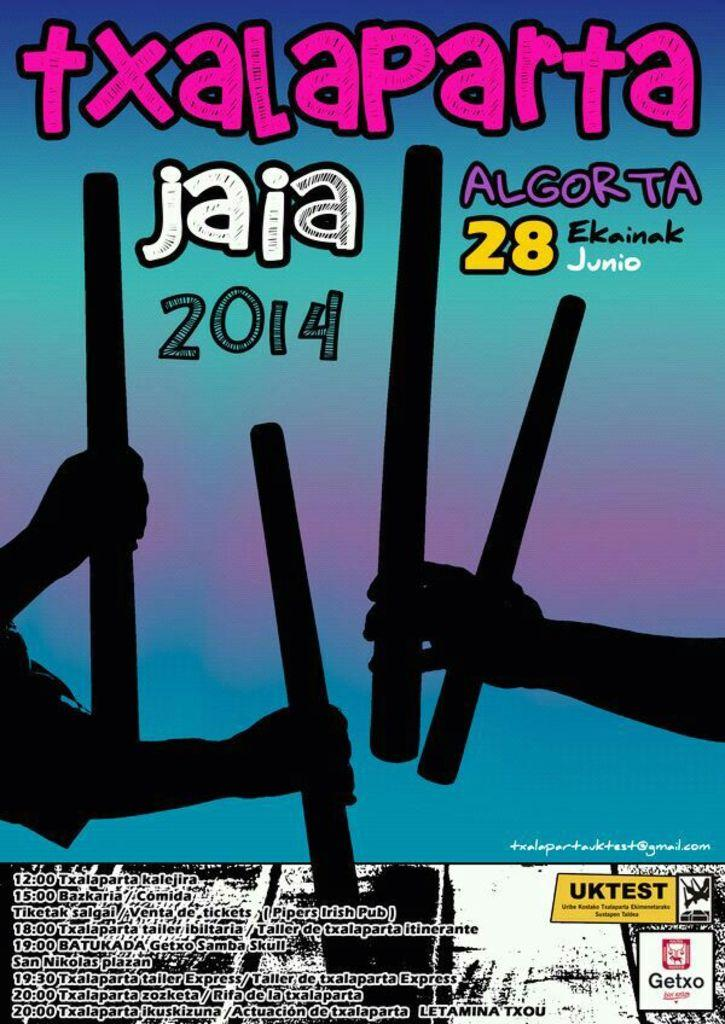<image>
Relay a brief, clear account of the picture shown. A blue and purple paper with people holding drumsticks that says txalaparta. 